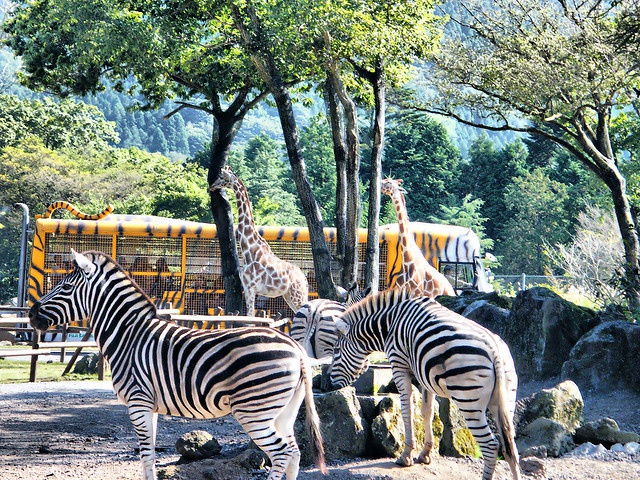Describe the objects in this image and their specific colors. I can see zebra in lightblue, black, lightgray, darkgray, and gray tones, bus in lightblue, gray, white, black, and orange tones, zebra in lightblue, darkgray, black, white, and gray tones, giraffe in lightblue, lightgray, darkgray, gray, and tan tones, and giraffe in lightblue, white, brown, and tan tones in this image. 